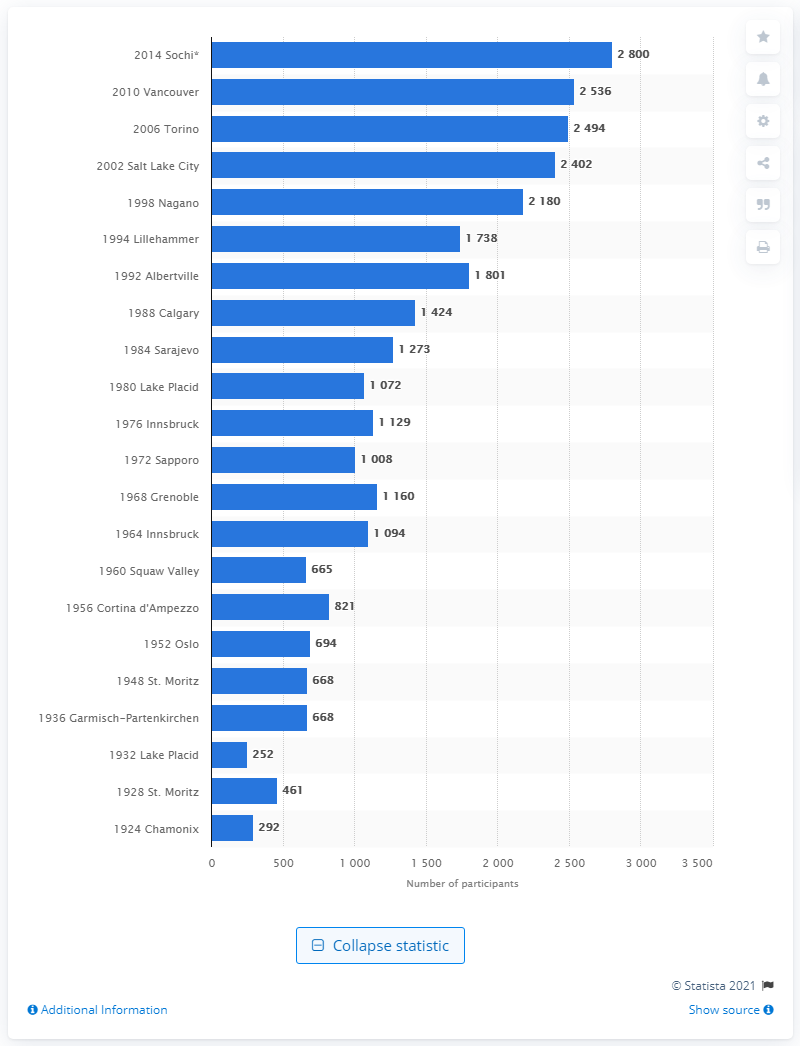Mention a couple of crucial points in this snapshot. In the first Olympic Winter Games held in Chamonix in 1924, a total of 292 athletes participated. 